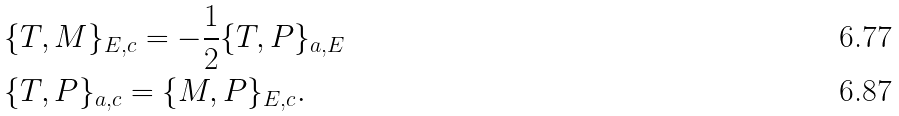Convert formula to latex. <formula><loc_0><loc_0><loc_500><loc_500>& \{ T , M \} _ { E , c } = - \frac { 1 } { 2 } \{ T , P \} _ { a , E } \\ & \{ T , P \} _ { a , c } = \{ M , P \} _ { E , c } .</formula> 